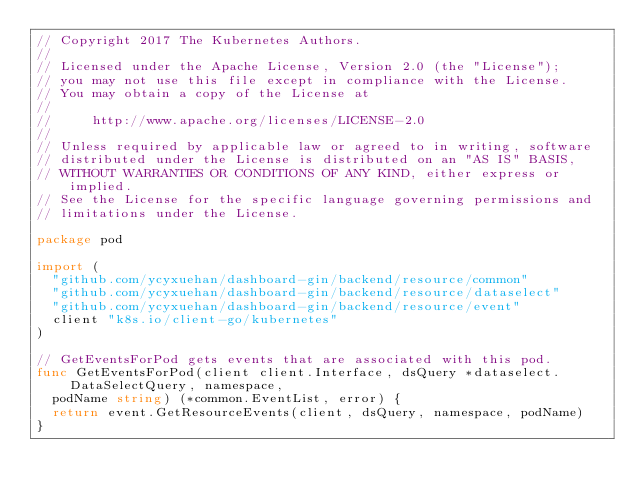<code> <loc_0><loc_0><loc_500><loc_500><_Go_>// Copyright 2017 The Kubernetes Authors.
//
// Licensed under the Apache License, Version 2.0 (the "License");
// you may not use this file except in compliance with the License.
// You may obtain a copy of the License at
//
//     http://www.apache.org/licenses/LICENSE-2.0
//
// Unless required by applicable law or agreed to in writing, software
// distributed under the License is distributed on an "AS IS" BASIS,
// WITHOUT WARRANTIES OR CONDITIONS OF ANY KIND, either express or implied.
// See the License for the specific language governing permissions and
// limitations under the License.

package pod

import (
	"github.com/ycyxuehan/dashboard-gin/backend/resource/common"
	"github.com/ycyxuehan/dashboard-gin/backend/resource/dataselect"
	"github.com/ycyxuehan/dashboard-gin/backend/resource/event"
	client "k8s.io/client-go/kubernetes"
)

// GetEventsForPod gets events that are associated with this pod.
func GetEventsForPod(client client.Interface, dsQuery *dataselect.DataSelectQuery, namespace,
	podName string) (*common.EventList, error) {
	return event.GetResourceEvents(client, dsQuery, namespace, podName)
}
</code> 